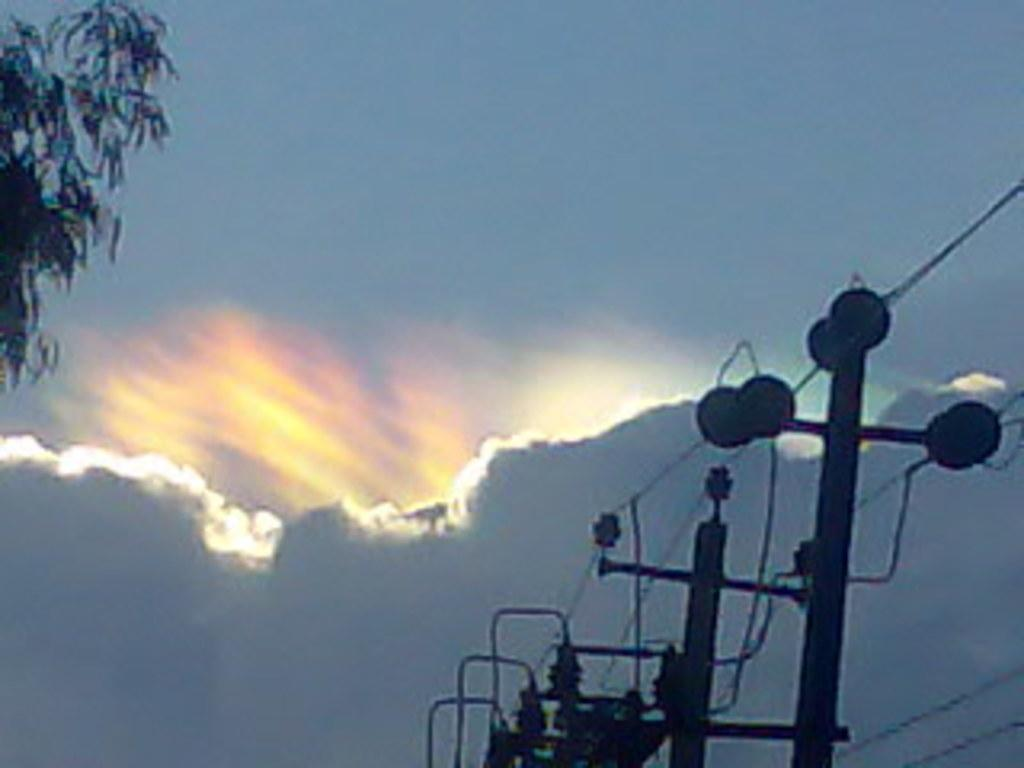What structures can be seen in the image? There are electrical poles in the image. What natural element is present in the top left of the image? There is a branch in the top left of the image. What can be seen in the sky in the image? There is a cloud visible in the sky. What type of skirt is being worn by the cloud in the image? There is no skirt present in the image, as clouds do not wear clothing. 